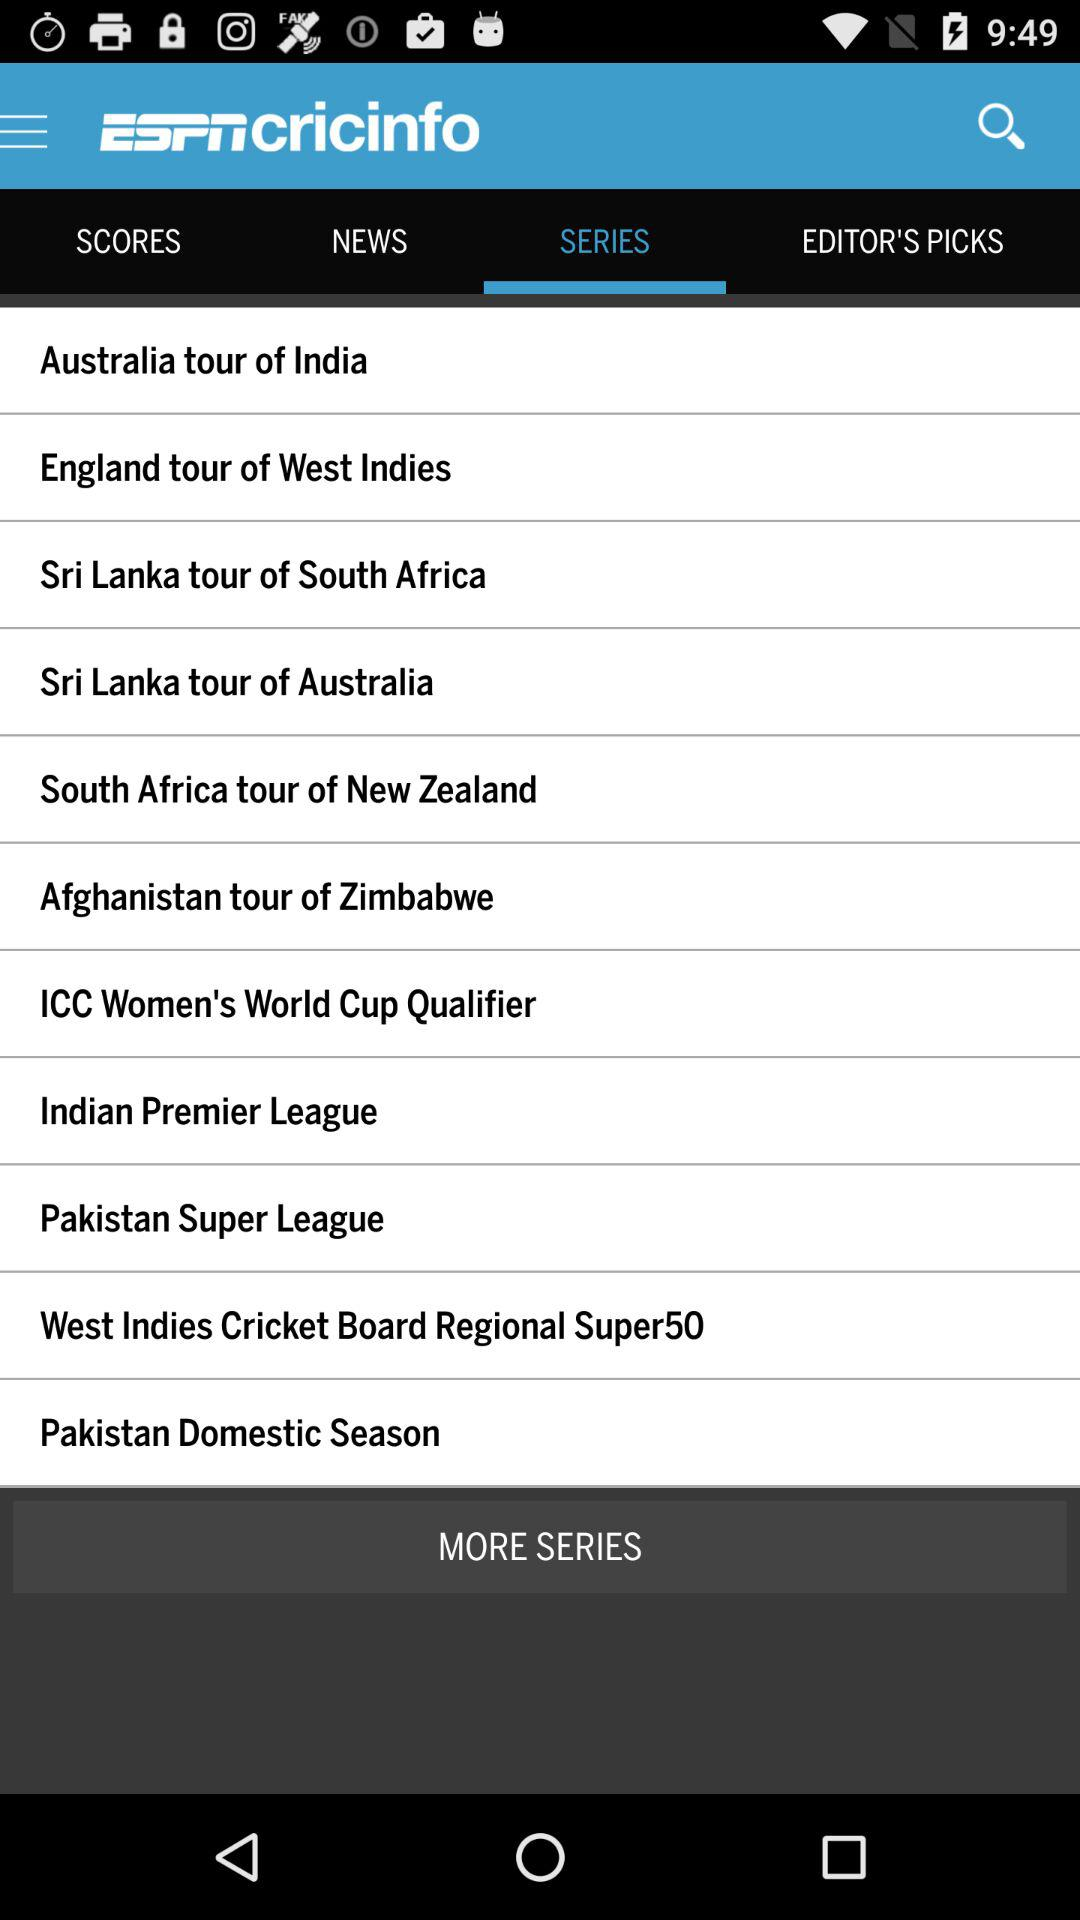Which tab am I on? You are on the "SERIES" tab. 